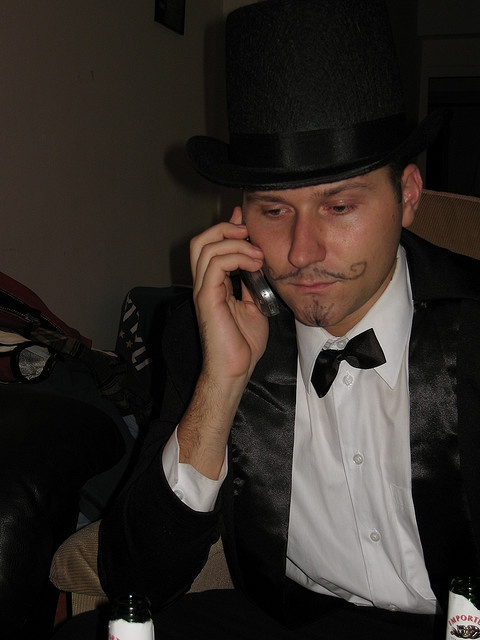Describe the objects in this image and their specific colors. I can see people in black, darkgray, and brown tones, dining table in black and gray tones, tie in black, gray, and darkgreen tones, bottle in black, lightgray, darkgray, and gray tones, and bottle in black, lightgray, darkgray, and gray tones in this image. 